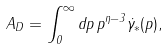<formula> <loc_0><loc_0><loc_500><loc_500>A _ { D } = \int _ { 0 } ^ { \infty } d p \, p ^ { \eta - 3 } \dot { \gamma } _ { * } ( p ) ,</formula> 